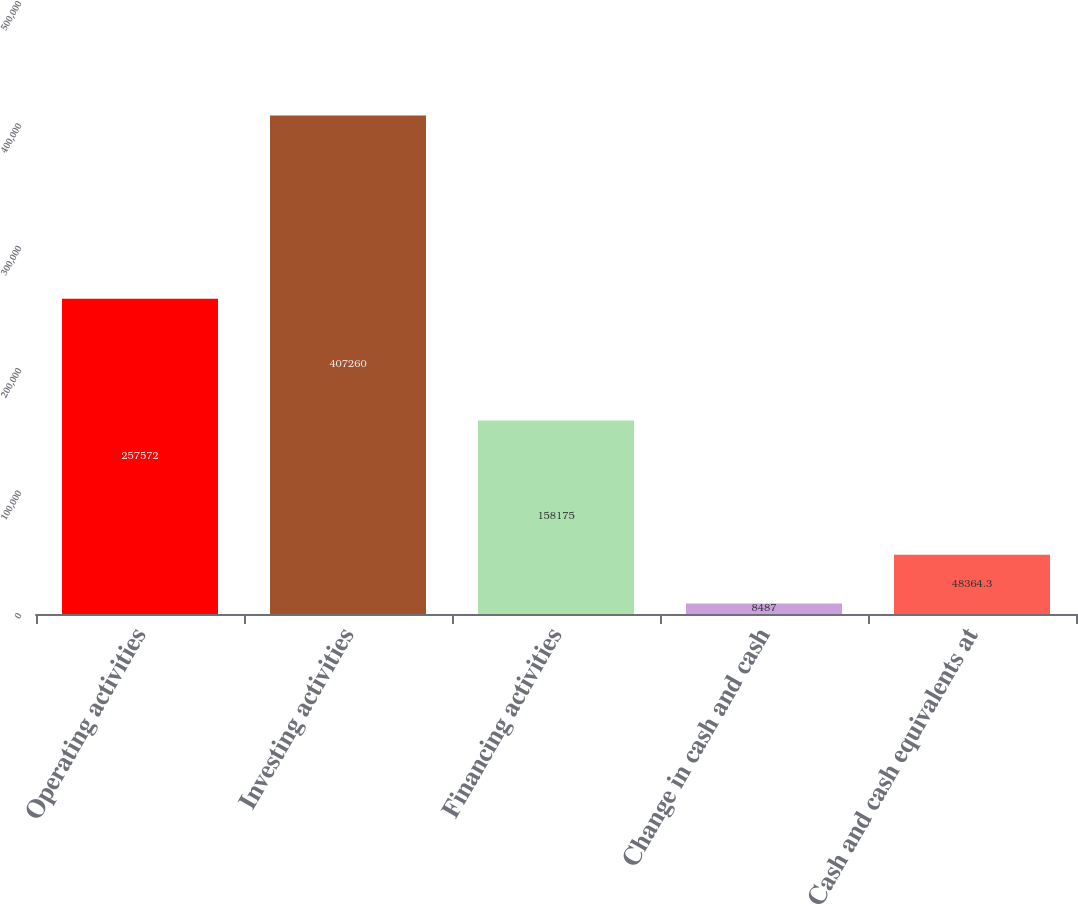Convert chart to OTSL. <chart><loc_0><loc_0><loc_500><loc_500><bar_chart><fcel>Operating activities<fcel>Investing activities<fcel>Financing activities<fcel>Change in cash and cash<fcel>Cash and cash equivalents at<nl><fcel>257572<fcel>407260<fcel>158175<fcel>8487<fcel>48364.3<nl></chart> 